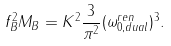<formula> <loc_0><loc_0><loc_500><loc_500>f _ { B } ^ { 2 } M _ { B } = K ^ { 2 } \frac { 3 } { \pi ^ { 2 } } ( \omega _ { 0 , d u a l } ^ { r e n } ) ^ { 3 } .</formula> 